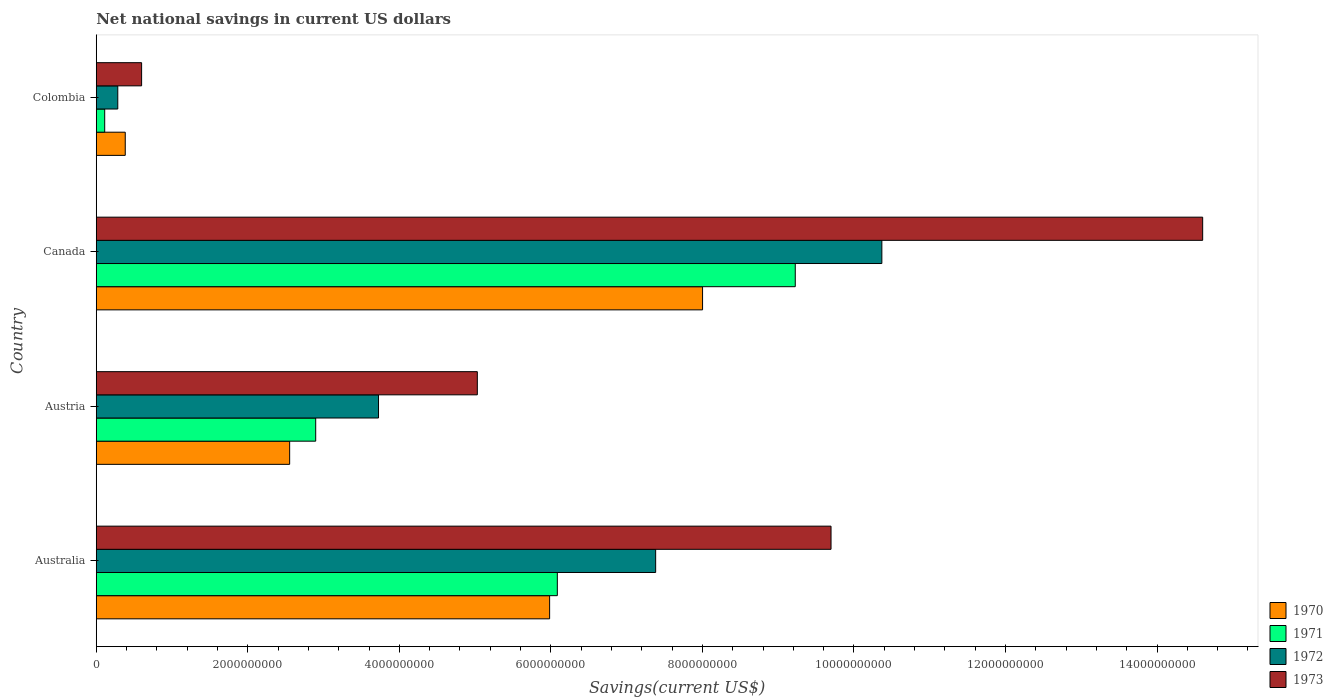How many groups of bars are there?
Keep it short and to the point. 4. Are the number of bars per tick equal to the number of legend labels?
Offer a very short reply. Yes. What is the net national savings in 1971 in Colombia?
Offer a very short reply. 1.11e+08. Across all countries, what is the maximum net national savings in 1972?
Make the answer very short. 1.04e+1. Across all countries, what is the minimum net national savings in 1972?
Keep it short and to the point. 2.84e+08. In which country was the net national savings in 1970 maximum?
Give a very brief answer. Canada. In which country was the net national savings in 1973 minimum?
Keep it short and to the point. Colombia. What is the total net national savings in 1970 in the graph?
Make the answer very short. 1.69e+1. What is the difference between the net national savings in 1973 in Australia and that in Colombia?
Your answer should be very brief. 9.10e+09. What is the difference between the net national savings in 1972 in Australia and the net national savings in 1973 in Colombia?
Make the answer very short. 6.78e+09. What is the average net national savings in 1970 per country?
Offer a terse response. 4.23e+09. What is the difference between the net national savings in 1970 and net national savings in 1972 in Australia?
Your answer should be compact. -1.40e+09. What is the ratio of the net national savings in 1971 in Austria to that in Colombia?
Offer a terse response. 25.99. What is the difference between the highest and the second highest net national savings in 1972?
Your answer should be compact. 2.99e+09. What is the difference between the highest and the lowest net national savings in 1972?
Provide a succinct answer. 1.01e+1. Is it the case that in every country, the sum of the net national savings in 1972 and net national savings in 1970 is greater than the net national savings in 1973?
Ensure brevity in your answer.  Yes. Are all the bars in the graph horizontal?
Your answer should be compact. Yes. Are the values on the major ticks of X-axis written in scientific E-notation?
Your answer should be compact. No. Does the graph contain any zero values?
Make the answer very short. No. Where does the legend appear in the graph?
Your answer should be very brief. Bottom right. How many legend labels are there?
Keep it short and to the point. 4. How are the legend labels stacked?
Your answer should be compact. Vertical. What is the title of the graph?
Your answer should be compact. Net national savings in current US dollars. Does "2011" appear as one of the legend labels in the graph?
Provide a succinct answer. No. What is the label or title of the X-axis?
Ensure brevity in your answer.  Savings(current US$). What is the label or title of the Y-axis?
Provide a succinct answer. Country. What is the Savings(current US$) in 1970 in Australia?
Ensure brevity in your answer.  5.98e+09. What is the Savings(current US$) of 1971 in Australia?
Keep it short and to the point. 6.09e+09. What is the Savings(current US$) of 1972 in Australia?
Keep it short and to the point. 7.38e+09. What is the Savings(current US$) of 1973 in Australia?
Provide a succinct answer. 9.70e+09. What is the Savings(current US$) in 1970 in Austria?
Offer a very short reply. 2.55e+09. What is the Savings(current US$) of 1971 in Austria?
Ensure brevity in your answer.  2.90e+09. What is the Savings(current US$) in 1972 in Austria?
Ensure brevity in your answer.  3.73e+09. What is the Savings(current US$) in 1973 in Austria?
Your response must be concise. 5.03e+09. What is the Savings(current US$) in 1970 in Canada?
Provide a succinct answer. 8.00e+09. What is the Savings(current US$) of 1971 in Canada?
Offer a terse response. 9.23e+09. What is the Savings(current US$) of 1972 in Canada?
Give a very brief answer. 1.04e+1. What is the Savings(current US$) of 1973 in Canada?
Give a very brief answer. 1.46e+1. What is the Savings(current US$) in 1970 in Colombia?
Your answer should be compact. 3.83e+08. What is the Savings(current US$) in 1971 in Colombia?
Your answer should be very brief. 1.11e+08. What is the Savings(current US$) in 1972 in Colombia?
Provide a succinct answer. 2.84e+08. What is the Savings(current US$) of 1973 in Colombia?
Provide a succinct answer. 5.98e+08. Across all countries, what is the maximum Savings(current US$) in 1970?
Offer a very short reply. 8.00e+09. Across all countries, what is the maximum Savings(current US$) of 1971?
Your answer should be compact. 9.23e+09. Across all countries, what is the maximum Savings(current US$) of 1972?
Your answer should be very brief. 1.04e+1. Across all countries, what is the maximum Savings(current US$) in 1973?
Keep it short and to the point. 1.46e+1. Across all countries, what is the minimum Savings(current US$) in 1970?
Your answer should be very brief. 3.83e+08. Across all countries, what is the minimum Savings(current US$) in 1971?
Give a very brief answer. 1.11e+08. Across all countries, what is the minimum Savings(current US$) in 1972?
Provide a succinct answer. 2.84e+08. Across all countries, what is the minimum Savings(current US$) in 1973?
Provide a succinct answer. 5.98e+08. What is the total Savings(current US$) in 1970 in the graph?
Your response must be concise. 1.69e+1. What is the total Savings(current US$) of 1971 in the graph?
Your response must be concise. 1.83e+1. What is the total Savings(current US$) of 1972 in the graph?
Offer a terse response. 2.18e+1. What is the total Savings(current US$) in 1973 in the graph?
Your response must be concise. 2.99e+1. What is the difference between the Savings(current US$) of 1970 in Australia and that in Austria?
Give a very brief answer. 3.43e+09. What is the difference between the Savings(current US$) of 1971 in Australia and that in Austria?
Offer a terse response. 3.19e+09. What is the difference between the Savings(current US$) in 1972 in Australia and that in Austria?
Give a very brief answer. 3.66e+09. What is the difference between the Savings(current US$) of 1973 in Australia and that in Austria?
Ensure brevity in your answer.  4.67e+09. What is the difference between the Savings(current US$) of 1970 in Australia and that in Canada?
Provide a succinct answer. -2.02e+09. What is the difference between the Savings(current US$) in 1971 in Australia and that in Canada?
Provide a succinct answer. -3.14e+09. What is the difference between the Savings(current US$) of 1972 in Australia and that in Canada?
Offer a very short reply. -2.99e+09. What is the difference between the Savings(current US$) of 1973 in Australia and that in Canada?
Provide a succinct answer. -4.90e+09. What is the difference between the Savings(current US$) of 1970 in Australia and that in Colombia?
Your answer should be compact. 5.60e+09. What is the difference between the Savings(current US$) of 1971 in Australia and that in Colombia?
Your answer should be very brief. 5.97e+09. What is the difference between the Savings(current US$) in 1972 in Australia and that in Colombia?
Offer a terse response. 7.10e+09. What is the difference between the Savings(current US$) of 1973 in Australia and that in Colombia?
Provide a short and direct response. 9.10e+09. What is the difference between the Savings(current US$) of 1970 in Austria and that in Canada?
Offer a very short reply. -5.45e+09. What is the difference between the Savings(current US$) of 1971 in Austria and that in Canada?
Ensure brevity in your answer.  -6.33e+09. What is the difference between the Savings(current US$) in 1972 in Austria and that in Canada?
Keep it short and to the point. -6.64e+09. What is the difference between the Savings(current US$) of 1973 in Austria and that in Canada?
Provide a short and direct response. -9.57e+09. What is the difference between the Savings(current US$) in 1970 in Austria and that in Colombia?
Give a very brief answer. 2.17e+09. What is the difference between the Savings(current US$) of 1971 in Austria and that in Colombia?
Provide a short and direct response. 2.78e+09. What is the difference between the Savings(current US$) of 1972 in Austria and that in Colombia?
Keep it short and to the point. 3.44e+09. What is the difference between the Savings(current US$) in 1973 in Austria and that in Colombia?
Give a very brief answer. 4.43e+09. What is the difference between the Savings(current US$) in 1970 in Canada and that in Colombia?
Offer a very short reply. 7.62e+09. What is the difference between the Savings(current US$) of 1971 in Canada and that in Colombia?
Provide a short and direct response. 9.11e+09. What is the difference between the Savings(current US$) in 1972 in Canada and that in Colombia?
Provide a short and direct response. 1.01e+1. What is the difference between the Savings(current US$) of 1973 in Canada and that in Colombia?
Your answer should be compact. 1.40e+1. What is the difference between the Savings(current US$) of 1970 in Australia and the Savings(current US$) of 1971 in Austria?
Ensure brevity in your answer.  3.09e+09. What is the difference between the Savings(current US$) in 1970 in Australia and the Savings(current US$) in 1972 in Austria?
Offer a terse response. 2.26e+09. What is the difference between the Savings(current US$) of 1970 in Australia and the Savings(current US$) of 1973 in Austria?
Provide a succinct answer. 9.54e+08. What is the difference between the Savings(current US$) in 1971 in Australia and the Savings(current US$) in 1972 in Austria?
Give a very brief answer. 2.36e+09. What is the difference between the Savings(current US$) of 1971 in Australia and the Savings(current US$) of 1973 in Austria?
Provide a short and direct response. 1.06e+09. What is the difference between the Savings(current US$) of 1972 in Australia and the Savings(current US$) of 1973 in Austria?
Keep it short and to the point. 2.35e+09. What is the difference between the Savings(current US$) of 1970 in Australia and the Savings(current US$) of 1971 in Canada?
Give a very brief answer. -3.24e+09. What is the difference between the Savings(current US$) in 1970 in Australia and the Savings(current US$) in 1972 in Canada?
Your response must be concise. -4.38e+09. What is the difference between the Savings(current US$) in 1970 in Australia and the Savings(current US$) in 1973 in Canada?
Ensure brevity in your answer.  -8.62e+09. What is the difference between the Savings(current US$) in 1971 in Australia and the Savings(current US$) in 1972 in Canada?
Provide a short and direct response. -4.28e+09. What is the difference between the Savings(current US$) in 1971 in Australia and the Savings(current US$) in 1973 in Canada?
Keep it short and to the point. -8.52e+09. What is the difference between the Savings(current US$) of 1972 in Australia and the Savings(current US$) of 1973 in Canada?
Your answer should be very brief. -7.22e+09. What is the difference between the Savings(current US$) of 1970 in Australia and the Savings(current US$) of 1971 in Colombia?
Ensure brevity in your answer.  5.87e+09. What is the difference between the Savings(current US$) in 1970 in Australia and the Savings(current US$) in 1972 in Colombia?
Offer a very short reply. 5.70e+09. What is the difference between the Savings(current US$) of 1970 in Australia and the Savings(current US$) of 1973 in Colombia?
Give a very brief answer. 5.38e+09. What is the difference between the Savings(current US$) in 1971 in Australia and the Savings(current US$) in 1972 in Colombia?
Provide a short and direct response. 5.80e+09. What is the difference between the Savings(current US$) in 1971 in Australia and the Savings(current US$) in 1973 in Colombia?
Your answer should be compact. 5.49e+09. What is the difference between the Savings(current US$) in 1972 in Australia and the Savings(current US$) in 1973 in Colombia?
Offer a terse response. 6.78e+09. What is the difference between the Savings(current US$) of 1970 in Austria and the Savings(current US$) of 1971 in Canada?
Ensure brevity in your answer.  -6.67e+09. What is the difference between the Savings(current US$) of 1970 in Austria and the Savings(current US$) of 1972 in Canada?
Give a very brief answer. -7.82e+09. What is the difference between the Savings(current US$) in 1970 in Austria and the Savings(current US$) in 1973 in Canada?
Provide a succinct answer. -1.20e+1. What is the difference between the Savings(current US$) in 1971 in Austria and the Savings(current US$) in 1972 in Canada?
Keep it short and to the point. -7.47e+09. What is the difference between the Savings(current US$) in 1971 in Austria and the Savings(current US$) in 1973 in Canada?
Ensure brevity in your answer.  -1.17e+1. What is the difference between the Savings(current US$) in 1972 in Austria and the Savings(current US$) in 1973 in Canada?
Provide a succinct answer. -1.09e+1. What is the difference between the Savings(current US$) in 1970 in Austria and the Savings(current US$) in 1971 in Colombia?
Your response must be concise. 2.44e+09. What is the difference between the Savings(current US$) of 1970 in Austria and the Savings(current US$) of 1972 in Colombia?
Ensure brevity in your answer.  2.27e+09. What is the difference between the Savings(current US$) of 1970 in Austria and the Savings(current US$) of 1973 in Colombia?
Ensure brevity in your answer.  1.95e+09. What is the difference between the Savings(current US$) in 1971 in Austria and the Savings(current US$) in 1972 in Colombia?
Offer a terse response. 2.61e+09. What is the difference between the Savings(current US$) of 1971 in Austria and the Savings(current US$) of 1973 in Colombia?
Keep it short and to the point. 2.30e+09. What is the difference between the Savings(current US$) of 1972 in Austria and the Savings(current US$) of 1973 in Colombia?
Your response must be concise. 3.13e+09. What is the difference between the Savings(current US$) in 1970 in Canada and the Savings(current US$) in 1971 in Colombia?
Keep it short and to the point. 7.89e+09. What is the difference between the Savings(current US$) of 1970 in Canada and the Savings(current US$) of 1972 in Colombia?
Make the answer very short. 7.72e+09. What is the difference between the Savings(current US$) in 1970 in Canada and the Savings(current US$) in 1973 in Colombia?
Give a very brief answer. 7.40e+09. What is the difference between the Savings(current US$) of 1971 in Canada and the Savings(current US$) of 1972 in Colombia?
Give a very brief answer. 8.94e+09. What is the difference between the Savings(current US$) in 1971 in Canada and the Savings(current US$) in 1973 in Colombia?
Your response must be concise. 8.63e+09. What is the difference between the Savings(current US$) in 1972 in Canada and the Savings(current US$) in 1973 in Colombia?
Make the answer very short. 9.77e+09. What is the average Savings(current US$) of 1970 per country?
Your response must be concise. 4.23e+09. What is the average Savings(current US$) of 1971 per country?
Your response must be concise. 4.58e+09. What is the average Savings(current US$) of 1972 per country?
Make the answer very short. 5.44e+09. What is the average Savings(current US$) of 1973 per country?
Offer a terse response. 7.48e+09. What is the difference between the Savings(current US$) in 1970 and Savings(current US$) in 1971 in Australia?
Keep it short and to the point. -1.02e+08. What is the difference between the Savings(current US$) in 1970 and Savings(current US$) in 1972 in Australia?
Provide a short and direct response. -1.40e+09. What is the difference between the Savings(current US$) in 1970 and Savings(current US$) in 1973 in Australia?
Your answer should be very brief. -3.71e+09. What is the difference between the Savings(current US$) in 1971 and Savings(current US$) in 1972 in Australia?
Give a very brief answer. -1.30e+09. What is the difference between the Savings(current US$) of 1971 and Savings(current US$) of 1973 in Australia?
Your response must be concise. -3.61e+09. What is the difference between the Savings(current US$) in 1972 and Savings(current US$) in 1973 in Australia?
Give a very brief answer. -2.31e+09. What is the difference between the Savings(current US$) in 1970 and Savings(current US$) in 1971 in Austria?
Your response must be concise. -3.44e+08. What is the difference between the Savings(current US$) in 1970 and Savings(current US$) in 1972 in Austria?
Offer a terse response. -1.17e+09. What is the difference between the Savings(current US$) of 1970 and Savings(current US$) of 1973 in Austria?
Give a very brief answer. -2.48e+09. What is the difference between the Savings(current US$) in 1971 and Savings(current US$) in 1972 in Austria?
Provide a short and direct response. -8.29e+08. What is the difference between the Savings(current US$) in 1971 and Savings(current US$) in 1973 in Austria?
Your answer should be very brief. -2.13e+09. What is the difference between the Savings(current US$) in 1972 and Savings(current US$) in 1973 in Austria?
Give a very brief answer. -1.30e+09. What is the difference between the Savings(current US$) in 1970 and Savings(current US$) in 1971 in Canada?
Ensure brevity in your answer.  -1.22e+09. What is the difference between the Savings(current US$) of 1970 and Savings(current US$) of 1972 in Canada?
Offer a terse response. -2.37e+09. What is the difference between the Savings(current US$) of 1970 and Savings(current US$) of 1973 in Canada?
Offer a terse response. -6.60e+09. What is the difference between the Savings(current US$) in 1971 and Savings(current US$) in 1972 in Canada?
Provide a succinct answer. -1.14e+09. What is the difference between the Savings(current US$) in 1971 and Savings(current US$) in 1973 in Canada?
Ensure brevity in your answer.  -5.38e+09. What is the difference between the Savings(current US$) in 1972 and Savings(current US$) in 1973 in Canada?
Your response must be concise. -4.23e+09. What is the difference between the Savings(current US$) in 1970 and Savings(current US$) in 1971 in Colombia?
Offer a terse response. 2.71e+08. What is the difference between the Savings(current US$) of 1970 and Savings(current US$) of 1972 in Colombia?
Your response must be concise. 9.87e+07. What is the difference between the Savings(current US$) of 1970 and Savings(current US$) of 1973 in Colombia?
Your response must be concise. -2.16e+08. What is the difference between the Savings(current US$) in 1971 and Savings(current US$) in 1972 in Colombia?
Your answer should be compact. -1.73e+08. What is the difference between the Savings(current US$) in 1971 and Savings(current US$) in 1973 in Colombia?
Offer a very short reply. -4.87e+08. What is the difference between the Savings(current US$) of 1972 and Savings(current US$) of 1973 in Colombia?
Offer a terse response. -3.14e+08. What is the ratio of the Savings(current US$) in 1970 in Australia to that in Austria?
Offer a very short reply. 2.34. What is the ratio of the Savings(current US$) in 1971 in Australia to that in Austria?
Provide a short and direct response. 2.1. What is the ratio of the Savings(current US$) in 1972 in Australia to that in Austria?
Your response must be concise. 1.98. What is the ratio of the Savings(current US$) of 1973 in Australia to that in Austria?
Give a very brief answer. 1.93. What is the ratio of the Savings(current US$) in 1970 in Australia to that in Canada?
Your response must be concise. 0.75. What is the ratio of the Savings(current US$) of 1971 in Australia to that in Canada?
Your answer should be very brief. 0.66. What is the ratio of the Savings(current US$) of 1972 in Australia to that in Canada?
Make the answer very short. 0.71. What is the ratio of the Savings(current US$) in 1973 in Australia to that in Canada?
Your response must be concise. 0.66. What is the ratio of the Savings(current US$) of 1970 in Australia to that in Colombia?
Your response must be concise. 15.64. What is the ratio of the Savings(current US$) of 1971 in Australia to that in Colombia?
Your answer should be compact. 54.61. What is the ratio of the Savings(current US$) of 1972 in Australia to that in Colombia?
Make the answer very short. 26. What is the ratio of the Savings(current US$) of 1973 in Australia to that in Colombia?
Ensure brevity in your answer.  16.2. What is the ratio of the Savings(current US$) in 1970 in Austria to that in Canada?
Make the answer very short. 0.32. What is the ratio of the Savings(current US$) of 1971 in Austria to that in Canada?
Offer a very short reply. 0.31. What is the ratio of the Savings(current US$) in 1972 in Austria to that in Canada?
Your answer should be very brief. 0.36. What is the ratio of the Savings(current US$) of 1973 in Austria to that in Canada?
Offer a very short reply. 0.34. What is the ratio of the Savings(current US$) of 1970 in Austria to that in Colombia?
Your answer should be compact. 6.67. What is the ratio of the Savings(current US$) of 1971 in Austria to that in Colombia?
Make the answer very short. 25.99. What is the ratio of the Savings(current US$) in 1972 in Austria to that in Colombia?
Your response must be concise. 13.12. What is the ratio of the Savings(current US$) in 1973 in Austria to that in Colombia?
Ensure brevity in your answer.  8.4. What is the ratio of the Savings(current US$) of 1970 in Canada to that in Colombia?
Make the answer very short. 20.91. What is the ratio of the Savings(current US$) of 1971 in Canada to that in Colombia?
Your response must be concise. 82.79. What is the ratio of the Savings(current US$) of 1972 in Canada to that in Colombia?
Provide a succinct answer. 36.51. What is the ratio of the Savings(current US$) of 1973 in Canada to that in Colombia?
Your answer should be very brief. 24.4. What is the difference between the highest and the second highest Savings(current US$) in 1970?
Offer a very short reply. 2.02e+09. What is the difference between the highest and the second highest Savings(current US$) in 1971?
Ensure brevity in your answer.  3.14e+09. What is the difference between the highest and the second highest Savings(current US$) in 1972?
Make the answer very short. 2.99e+09. What is the difference between the highest and the second highest Savings(current US$) of 1973?
Your answer should be compact. 4.90e+09. What is the difference between the highest and the lowest Savings(current US$) in 1970?
Offer a very short reply. 7.62e+09. What is the difference between the highest and the lowest Savings(current US$) of 1971?
Make the answer very short. 9.11e+09. What is the difference between the highest and the lowest Savings(current US$) of 1972?
Your response must be concise. 1.01e+1. What is the difference between the highest and the lowest Savings(current US$) in 1973?
Keep it short and to the point. 1.40e+1. 